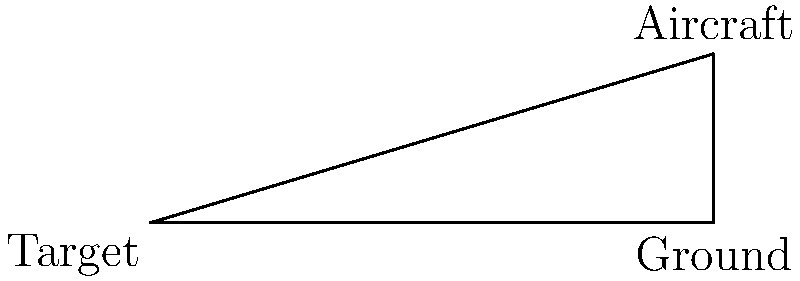As part of a military exercise focusing on precision targeting, an aircraft is flying at an altitude of 3000 meters. The pilot spots a ground target and measures the angle of depression to be 30°. Using this information, calculate the horizontal distance $d$ between the aircraft and the target on the ground. Round your answer to the nearest meter. Let's approach this step-by-step:

1) In this scenario, we have a right-angled triangle. The aircraft is at the top vertex, the target is at one base vertex, and the point directly below the aircraft forms the other base vertex.

2) We know:
   - The altitude (height) of the aircraft: $h = 3000$ meters
   - The angle of depression: $\theta = 30°$

3) The angle of depression is the angle between the horizontal line from the aircraft and the line of sight to the target. This forms the complementary angle to our right-angled triangle.

4) In a right-angled triangle, we can use the tangent function:

   $\tan \theta = \frac{\text{opposite}}{\text{adjacent}} = \frac{h}{d}$

5) Rearranging this equation:

   $d = \frac{h}{\tan \theta}$

6) Substituting our known values:

   $d = \frac{3000}{\tan 30°}$

7) $\tan 30° = \frac{1}{\sqrt{3}} \approx 0.5774$

8) Therefore:

   $d = \frac{3000}{0.5774} \approx 5196.15$ meters

9) Rounding to the nearest meter:

   $d \approx 5196$ meters
Answer: 5196 meters 